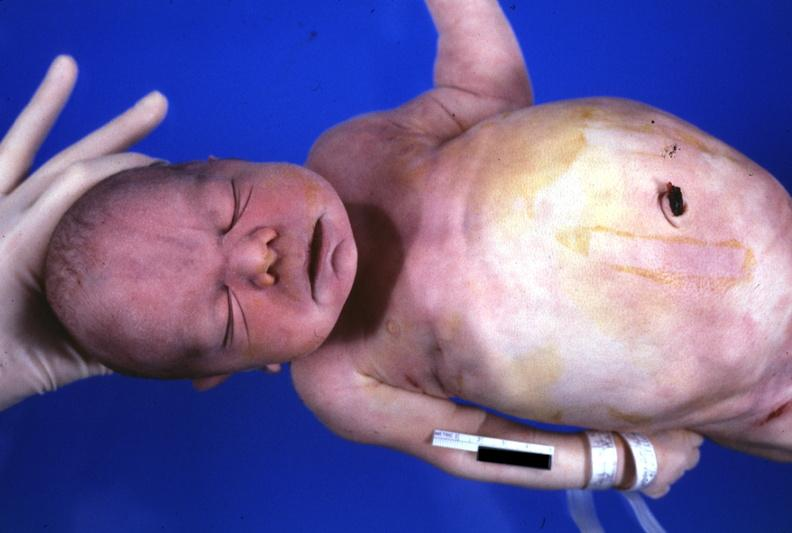what is present?
Answer the question using a single word or phrase. Potters facies 